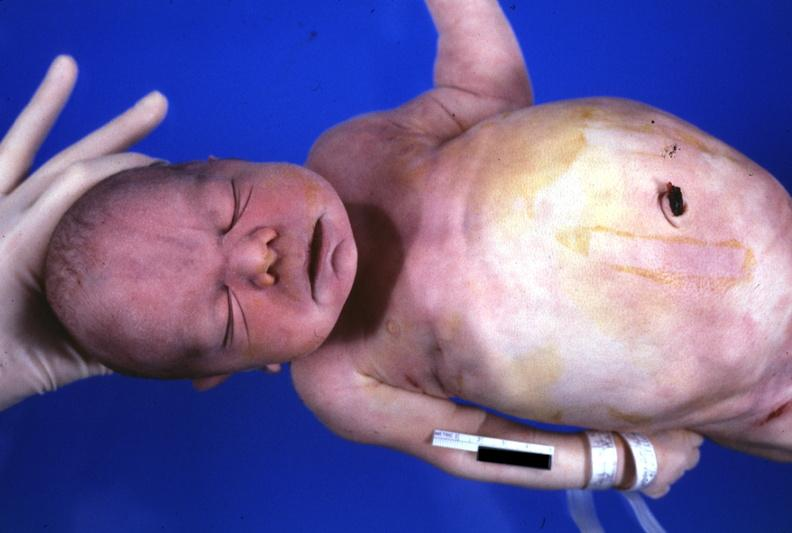what is present?
Answer the question using a single word or phrase. Potters facies 